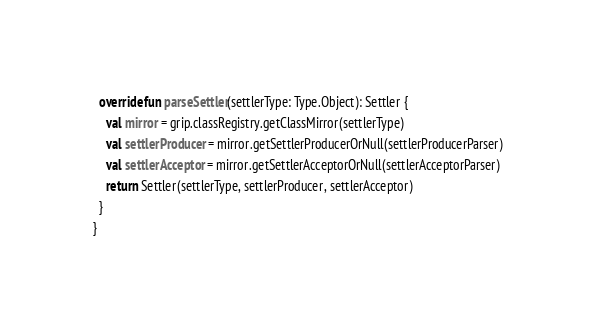<code> <loc_0><loc_0><loc_500><loc_500><_Kotlin_>
  override fun parseSettler(settlerType: Type.Object): Settler {
    val mirror = grip.classRegistry.getClassMirror(settlerType)
    val settlerProducer = mirror.getSettlerProducerOrNull(settlerProducerParser)
    val settlerAcceptor = mirror.getSettlerAcceptorOrNull(settlerAcceptorParser)
    return Settler(settlerType, settlerProducer, settlerAcceptor)
  }
}
</code> 